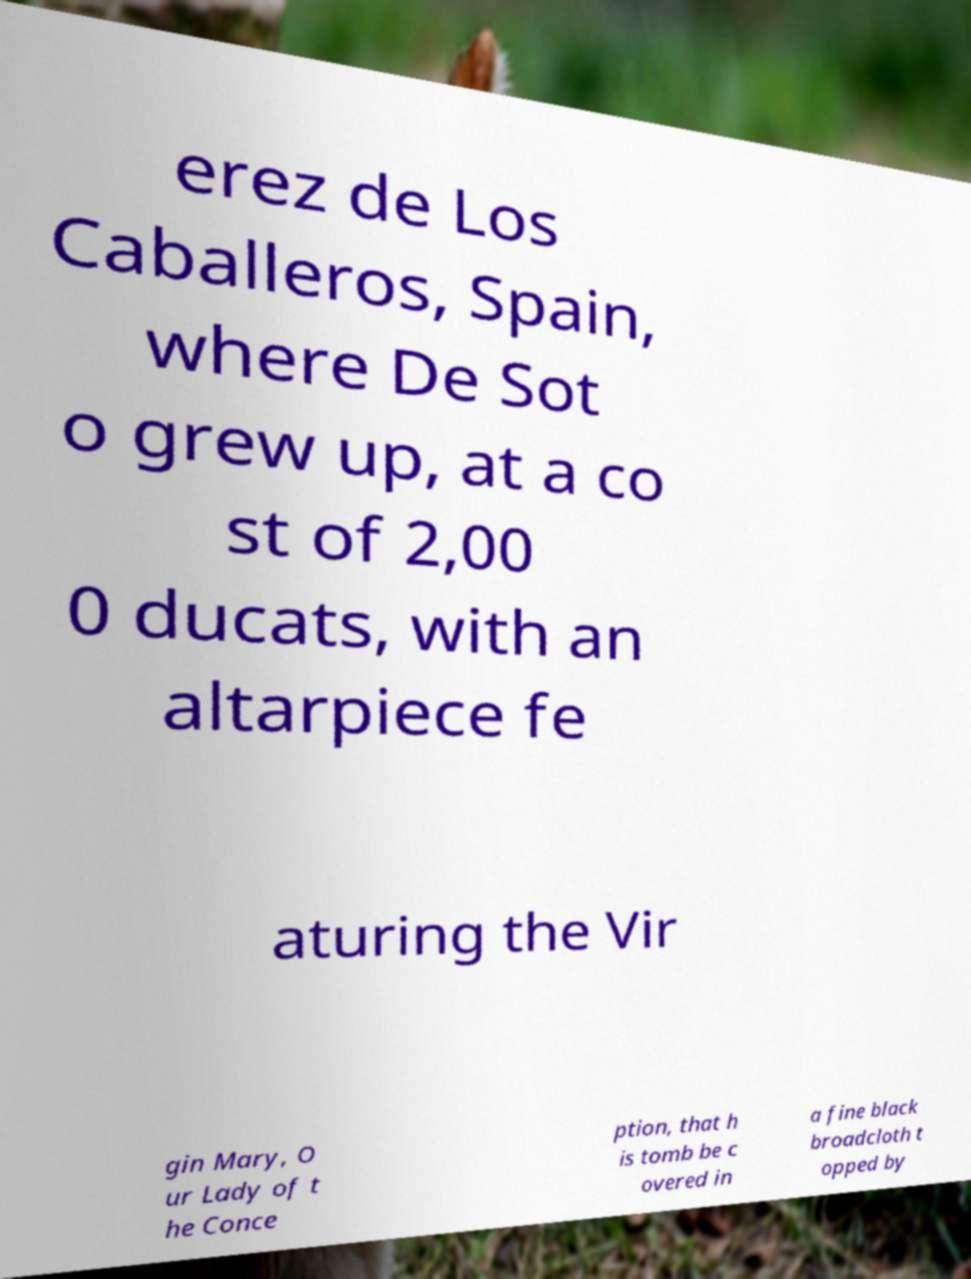For documentation purposes, I need the text within this image transcribed. Could you provide that? erez de Los Caballeros, Spain, where De Sot o grew up, at a co st of 2,00 0 ducats, with an altarpiece fe aturing the Vir gin Mary, O ur Lady of t he Conce ption, that h is tomb be c overed in a fine black broadcloth t opped by 